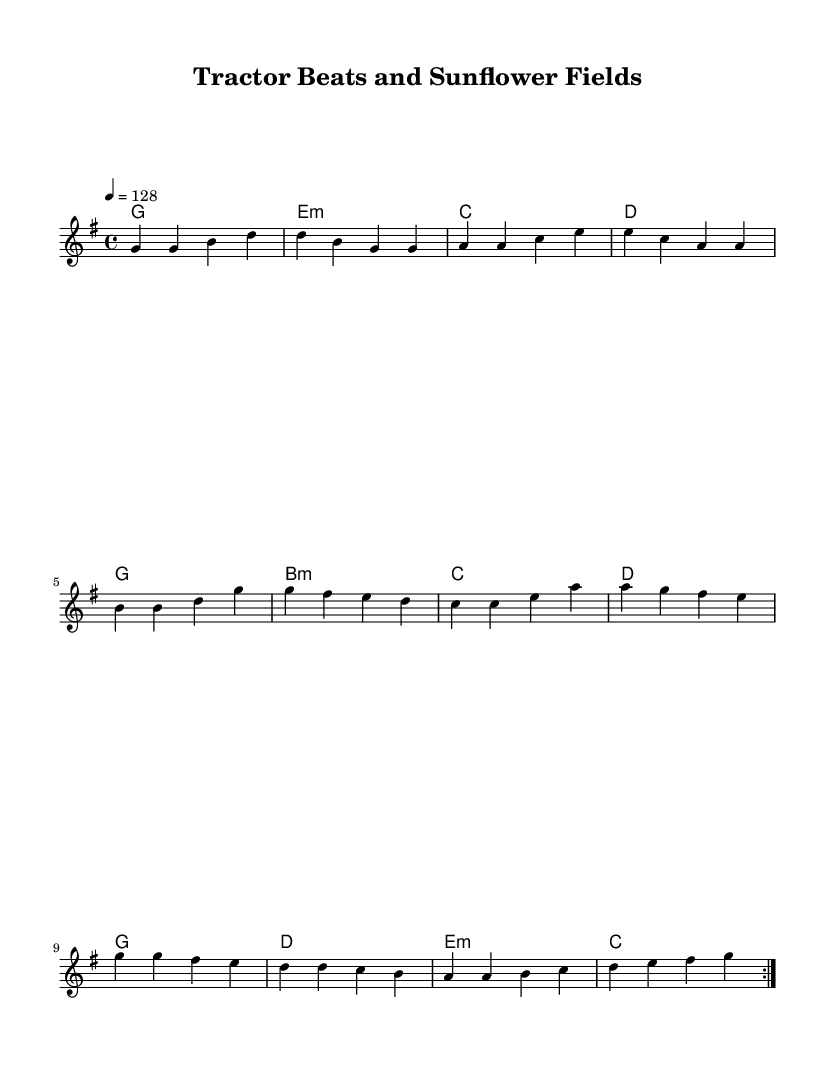What is the key signature of this music? The key signature is G major, which contains one sharp (F#). This can be identified from the beginning of the sheet music where the key signature is noted.
Answer: G major What is the time signature of this piece? The time signature is 4/4, which means there are four beats in each measure and each beat is a quarter note. This is indicated at the beginning of the score.
Answer: 4/4 What is the tempo marking for this piece? The tempo marking is 128 beats per minute, indicated in the tempo expression at the start of the sheet music. A higher number indicates a faster pace.
Answer: 128 How many measures are in the melody section? The melody section has a total of 16 measures, as observed from counting the repeating sections and their combination within the score layout.
Answer: 16 What chords are primarily used in the harmony section? The predominant chords used are G, E minor, C, and D, which can be identified by looking at the chord symbols in the harmony section.
Answer: G, E minor, C, D Which instrument is implied by the notation structure? The notation structure implies that a piano or similar instrument would be appropriate, as the presence of chords and melody lines indicates that harmonic playing is required.
Answer: Piano What genre does this sheet music belong to? The genre of the music is characterized as "Dance," specifically a country-pop dance remix style that reflects farm life themes, as suggested by the title and overall content.
Answer: Dance 